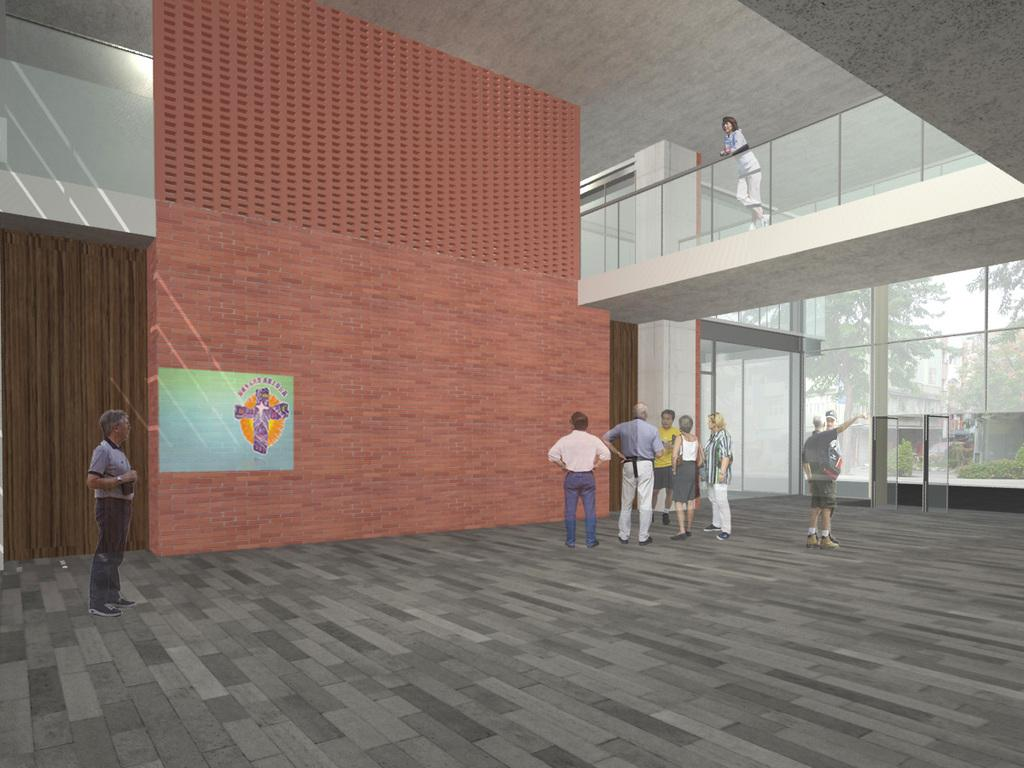What can be seen in the image? There are people standing in the image. What is the background of the image? There is a wall in the image. What is the surface on which the people are standing? There is a floor in the image. What type of media is the image? The image is animated. Where is the representative's nest located in the image? There is no representative or nest present in the image. What type of sand can be seen on the floor in the image? There is no sand present in the image; it features a floor. 